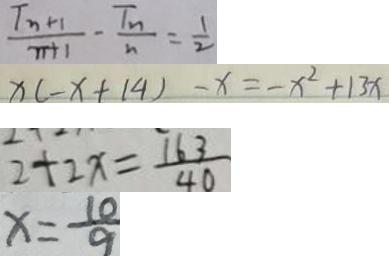Convert formula to latex. <formula><loc_0><loc_0><loc_500><loc_500>\frac { T _ { n } + 1 } { n + 1 } - \frac { T _ { n } } { n } = \frac { 1 } { 2 } 
 x ( - x + 1 4 ) - x = - x ^ { 2 } + 1 3 x 
 2 + 2 x = \frac { 1 6 3 } { 4 0 } 
 x = \frac { 1 0 } { 9 }</formula> 